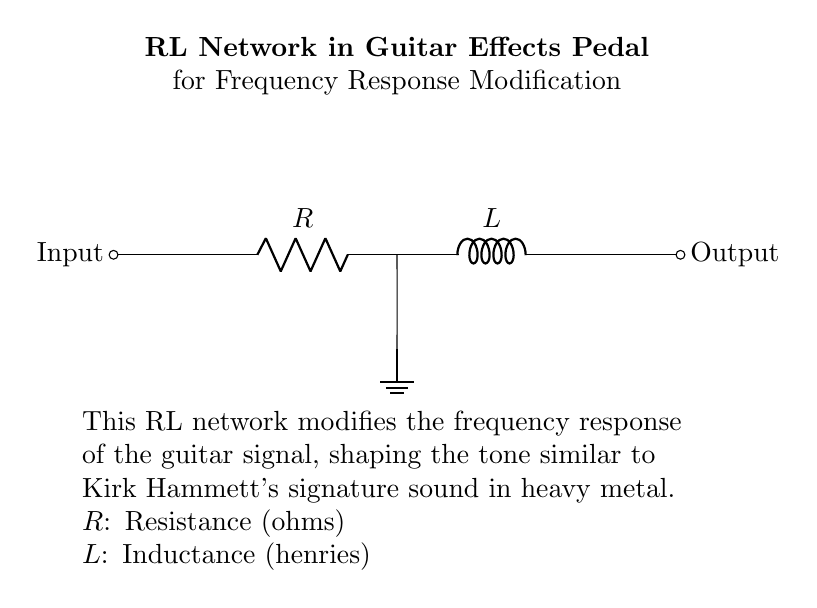What is the input of this circuit? The input is shown as the starting point in the circuit diagram, indicated by the label "Input" on the left side, which connects to the rest of the components.
Answer: Input What type of components are present in this circuit? The circuit includes a resistor and an inductor, specifically labeled as "R" and "L," which indicate their respective roles in modifying the guitar signal's frequency response.
Answer: Resistor and Inductor What does the inductor do in this circuit? The inductor in the circuit serves to store energy in a magnetic field when current passes through it, which impacts the signal's frequency response, promoting better tone control for guitar effects.
Answer: Store energy What is the purpose of the resistor in this RL network? The resistor dissipates energy as heat and limits the current flowing through the circuit, affecting the amplitude and quality of the output signal. This helps shape the overall tone of the guitar sound.
Answer: Limit current What happens to the output signal when the resistance is increased? Increasing the resistance will reduce the current flowing through the circuit, which can lead to a decrease in the output amplitude and affect the tone quality, potentially reducing the gain of the signal.
Answer: Decrease amplitude How does the inductance value affect the frequency response of the circuit? The inductance value determines how the circuit responds to different frequencies; higher inductance values tend to allow lower frequencies to pass while attenuating higher frequencies, effectively shaping the sound signature.
Answer: Shapes frequency response 